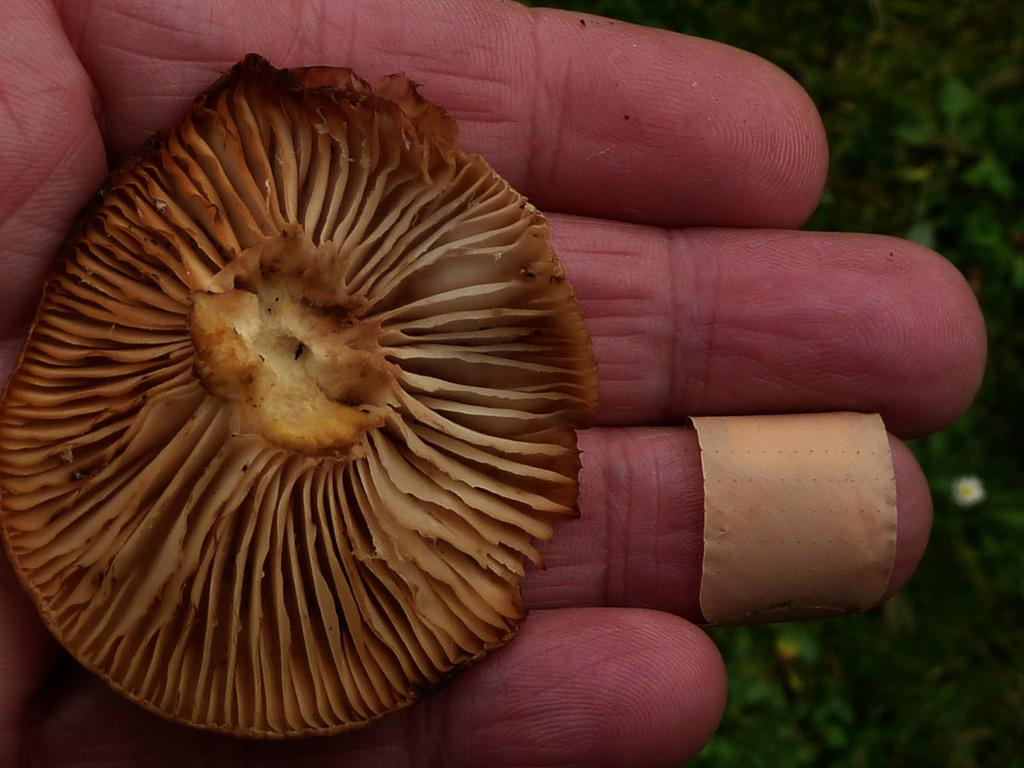What is on the person's hand in the image? There is a mushroom on the person's hand. What is on the person's finger in the image? There is a bandage on the person's finger. What can be seen in the background of the image? There are trees in the background of the image. What song is the person singing in the image? There is no indication in the image that the person is singing a song. How many teeth can be seen in the image? There are no teeth visible in the image, as it features a person with a mushroom on their hand and a bandage on their finger. 